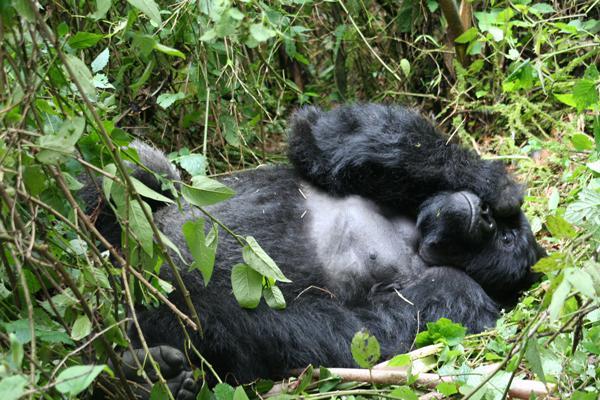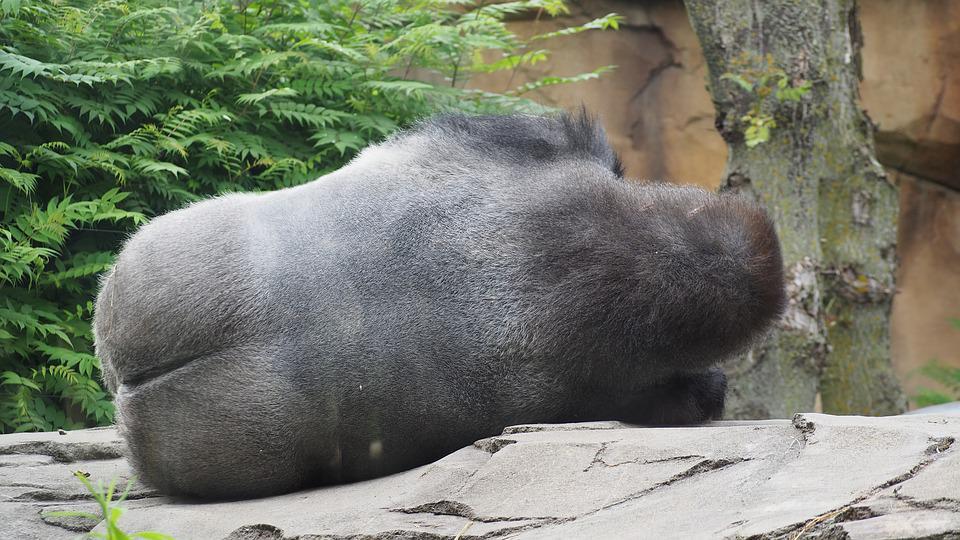The first image is the image on the left, the second image is the image on the right. Assess this claim about the two images: "There are two gorillas laying down". Correct or not? Answer yes or no. Yes. The first image is the image on the left, the second image is the image on the right. Analyze the images presented: Is the assertion "The right image contains a gorilla lying on the grass with its head facing forward and the top of its head on the right." valid? Answer yes or no. No. 